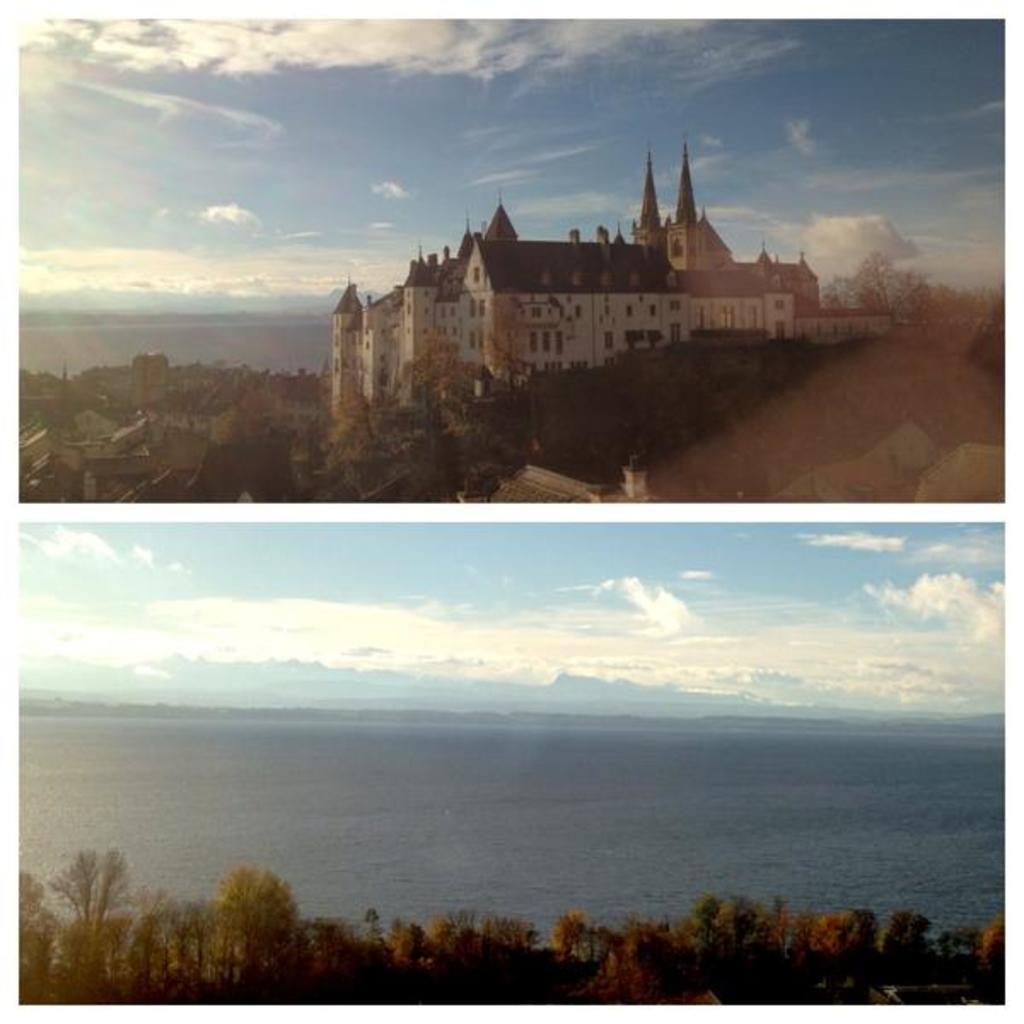What type of artwork is the image? The image is a collage. What structures can be seen in the collage? There are buildings in the image. What type of natural environment is depicted in the collage? There are trees and a sea in the image. What part of the natural environment is visible in the image? The sky is visible in the image. What type of force is being applied to the jelly in the image? There is no jelly present in the image, so no force can be applied to it. How does the love between the trees and buildings manifest in the image? The image is a collage of various elements, including buildings and trees, but there is no indication of love between them. 